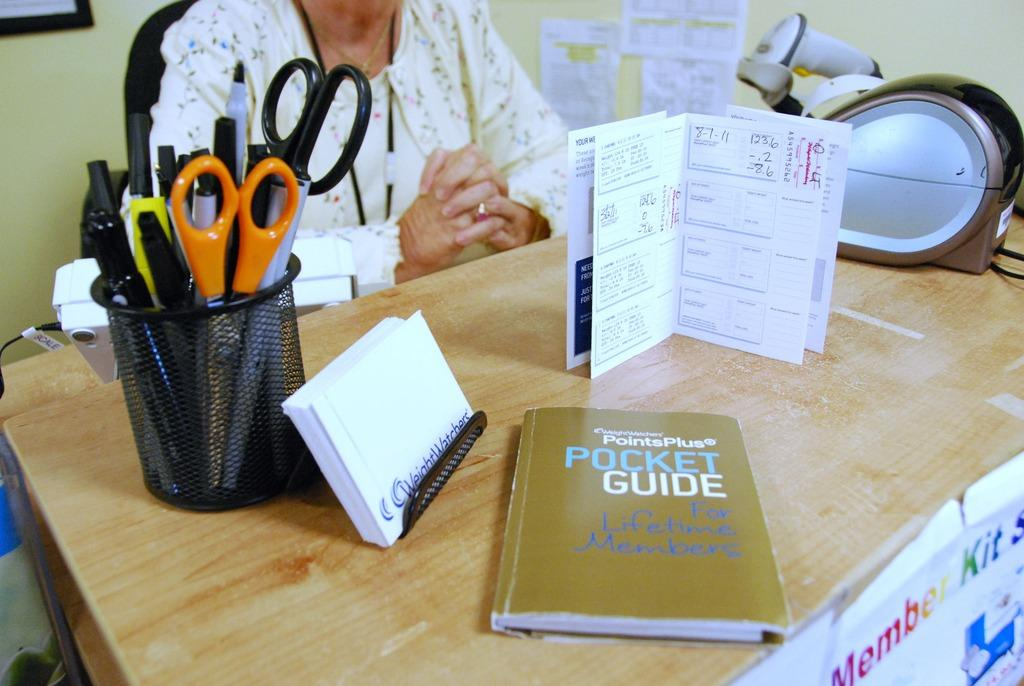<image>
Share a concise interpretation of the image provided. A book with the title Pocket Guide is on a desk that a person sits at. 